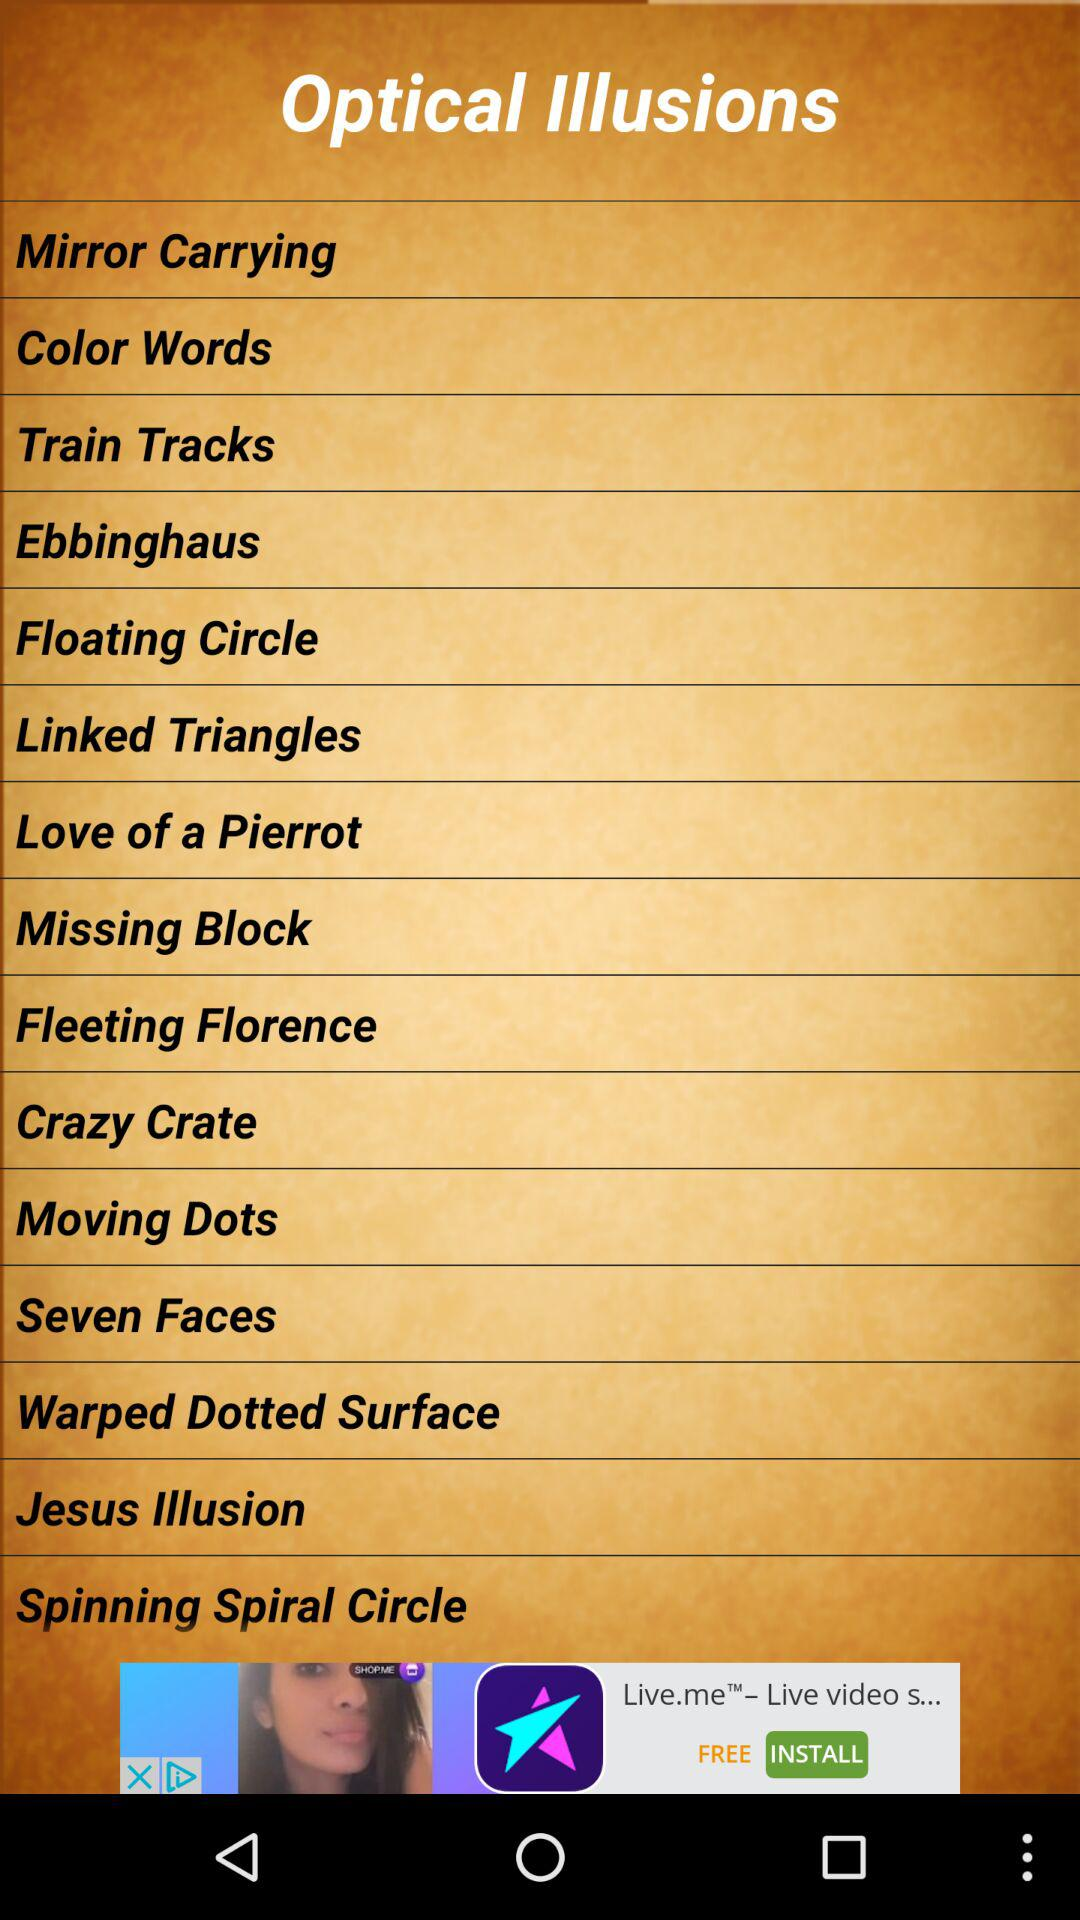What is the application name? The application name is "Optical Illusions". 